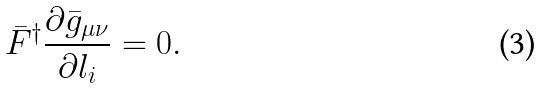<formula> <loc_0><loc_0><loc_500><loc_500>\bar { F } ^ { \dagger } \frac { \partial \bar { g } _ { \mu \nu } } { \partial l _ { i } } = 0 .</formula> 